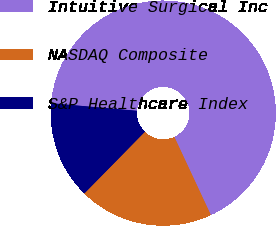Convert chart to OTSL. <chart><loc_0><loc_0><loc_500><loc_500><pie_chart><fcel>Intuitive Surgical Inc<fcel>NASDAQ Composite<fcel>S&P Healthcare Index<nl><fcel>66.64%<fcel>19.31%<fcel>14.05%<nl></chart> 